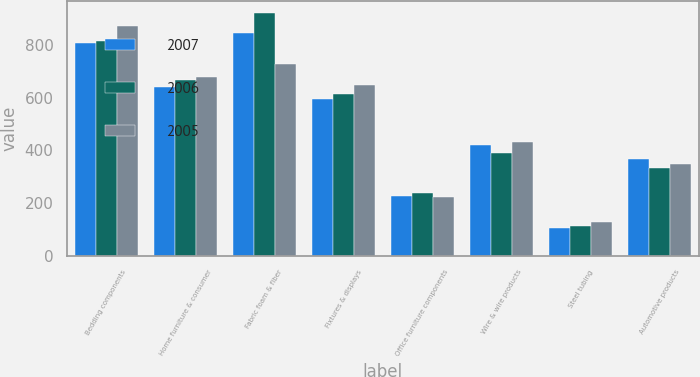Convert chart. <chart><loc_0><loc_0><loc_500><loc_500><stacked_bar_chart><ecel><fcel>Bedding components<fcel>Home furniture & consumer<fcel>Fabric foam & fiber<fcel>Fixtures & displays<fcel>Office furniture components<fcel>Wire & wire products<fcel>Steel tubing<fcel>Automotive products<nl><fcel>2007<fcel>806.6<fcel>641.7<fcel>846.5<fcel>593.1<fcel>226.7<fcel>419<fcel>104.1<fcel>366.5<nl><fcel>2006<fcel>813.6<fcel>667.7<fcel>921.1<fcel>613<fcel>237.5<fcel>391.2<fcel>113.2<fcel>332.6<nl><fcel>2005<fcel>870.2<fcel>678.3<fcel>726.6<fcel>648.5<fcel>221.8<fcel>431.7<fcel>129<fcel>348.1<nl></chart> 